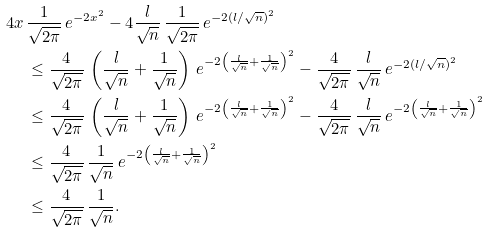<formula> <loc_0><loc_0><loc_500><loc_500>4 x \, & \frac { 1 } { \sqrt { 2 \pi } } \, e ^ { - 2 x ^ { 2 } } - 4 \frac { l } { \sqrt { n } } \, \frac { 1 } { \sqrt { 2 \pi } } \, e ^ { - 2 ( l / \sqrt { n } ) ^ { 2 } } \\ & \leq \frac { 4 } { \sqrt { 2 \pi } } \, \left ( \frac { l } { \sqrt { n } } + \frac { 1 } { \sqrt { n } } \right ) \, e ^ { - 2 \left ( \frac { l } { \sqrt { n } } + \frac { 1 } { \sqrt { n } } \right ) ^ { 2 } } - \frac { 4 } { \sqrt { 2 \pi } } \, \frac { l } { \sqrt { n } } \, e ^ { - 2 ( l / \sqrt { n } ) ^ { 2 } } \\ & \leq \frac { 4 } { \sqrt { 2 \pi } } \, \left ( \frac { l } { \sqrt { n } } + \frac { 1 } { \sqrt { n } } \right ) \, e ^ { - 2 \left ( \frac { l } { \sqrt { n } } + \frac { 1 } { \sqrt { n } } \right ) ^ { 2 } } - \frac { 4 } { \sqrt { 2 \pi } } \, \frac { l } { \sqrt { n } } \, e ^ { - 2 \left ( \frac { l } { \sqrt { n } } + \frac { 1 } { \sqrt { n } } \right ) ^ { 2 } } \\ & \leq \frac { 4 } { \sqrt { 2 \pi } } \, \frac { 1 } { \sqrt { n } } \, e ^ { - 2 \left ( \frac { l } { \sqrt { n } } + \frac { 1 } { \sqrt { n } } \right ) ^ { 2 } } \\ & \leq \frac { 4 } { \sqrt { 2 \pi } } \, \frac { 1 } { \sqrt { n } } .</formula> 